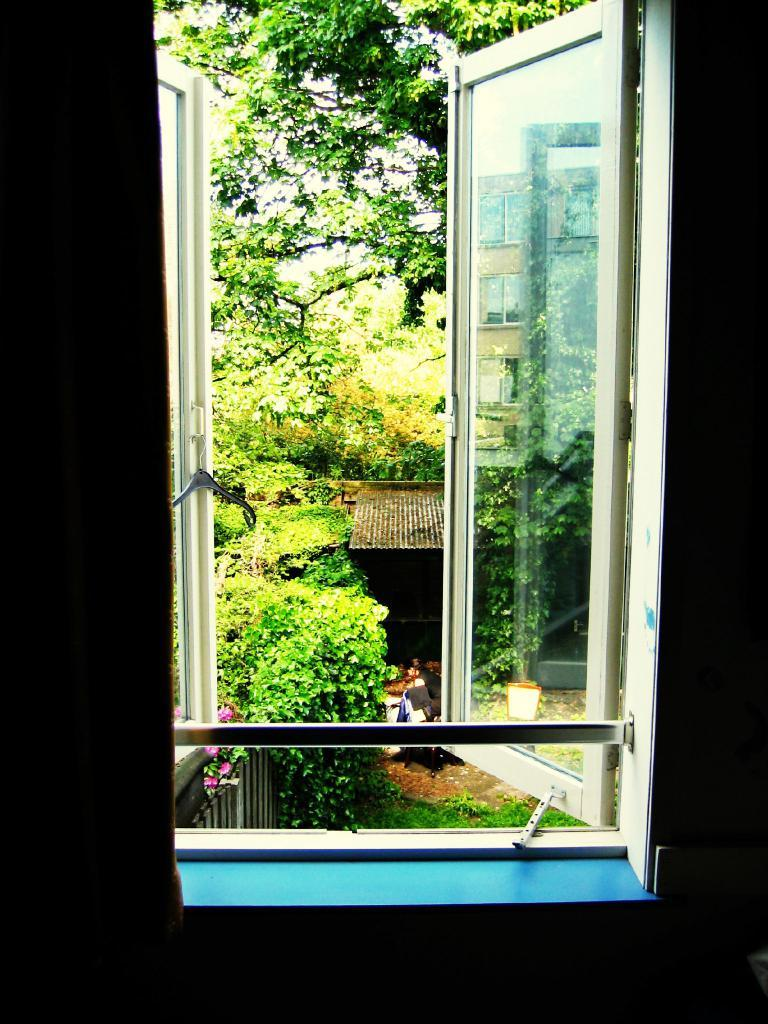What type of structure can be seen in the image? There is a glass window in the image. What natural elements are visible in the image? Trees, flowers, and grass are visible in the image. What type of fabric is present in the image? There is a sheet in the image. What type of insect is crawling on the selection of flowers in the image? There is no insect present in the image, and there is no selection of flowers mentioned in the facts. 